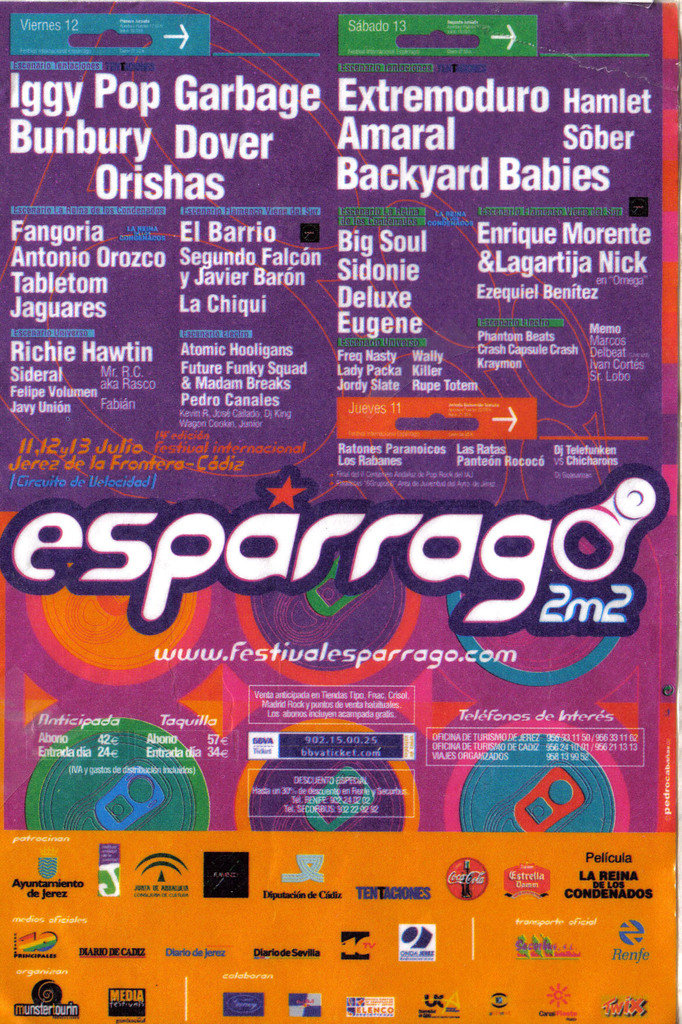What information is provided concerning tickets and venue? The poster outlines ticket prices and purchasing options: 42 euros in advance or 57 euros at the venue, with the event being held in Jerez at the 'Circuito de Velocidad.' It also mentions additional amenities and access details for potential visitors. 